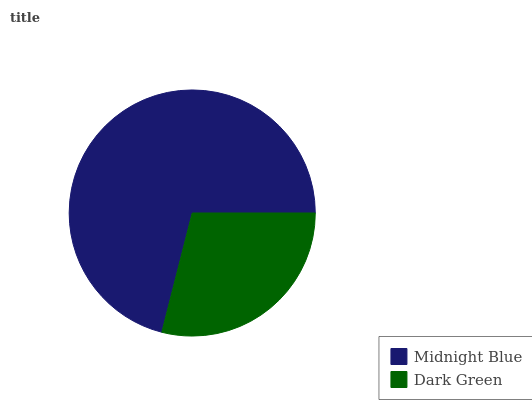Is Dark Green the minimum?
Answer yes or no. Yes. Is Midnight Blue the maximum?
Answer yes or no. Yes. Is Dark Green the maximum?
Answer yes or no. No. Is Midnight Blue greater than Dark Green?
Answer yes or no. Yes. Is Dark Green less than Midnight Blue?
Answer yes or no. Yes. Is Dark Green greater than Midnight Blue?
Answer yes or no. No. Is Midnight Blue less than Dark Green?
Answer yes or no. No. Is Midnight Blue the high median?
Answer yes or no. Yes. Is Dark Green the low median?
Answer yes or no. Yes. Is Dark Green the high median?
Answer yes or no. No. Is Midnight Blue the low median?
Answer yes or no. No. 